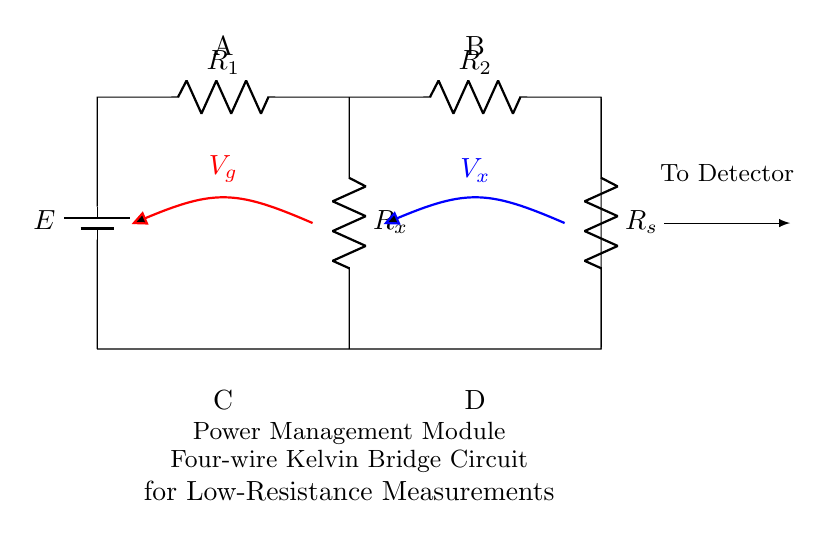What is the type of the circuit presented? The circuit is a four-wire Kelvin bridge, which is specifically designed for low-resistance measurements. The four-wire configuration helps eliminate the effects of lead resistance on the measurement accuracy.
Answer: four-wire Kelvin bridge What is connected to terminals A and B? Terminals A and B connect to resistors R1 and R2, respectively, forming the main circuit. These terminals are essential for applying the voltage across the resistors.
Answer: R1 and R2 What does the symbol in the bottom left represent? The symbol represents the Power Management Module, indicating the specific application context of the bridge circuit.
Answer: Power Management Module What are the voltage readings indicated in the circuit? The voltage readings are represented by Vg and Vx. Vg is the voltage across R1, while Vx is the voltage across the unknown resistance Rx.
Answer: Vg and Vx How many resistors are depicted in the circuit diagram? There are four resistors depicted: R1, R2, Rx, and Rs. The presence of these resistors is crucial for the operation of the bridge circuit.
Answer: four Why is the four-wire configuration advantageous for measuring low resistances? The four-wire configuration minimizes the error caused by the resistance of the measuring leads itself. By separating the current-carrying paths from the voltage-sensing paths, it ensures that only the voltage drop across the unknown resistor (Rx) is measured.
Answer: minimizes lead resistance error What is the function of the resistor Rs in this setup? Resistor Rs is typically used to provide a known reference resistance for balancing the bridge. This allows for accurate measurements of the unknown resistance by creating a ratio with R1 and R2.
Answer: reference resistance 